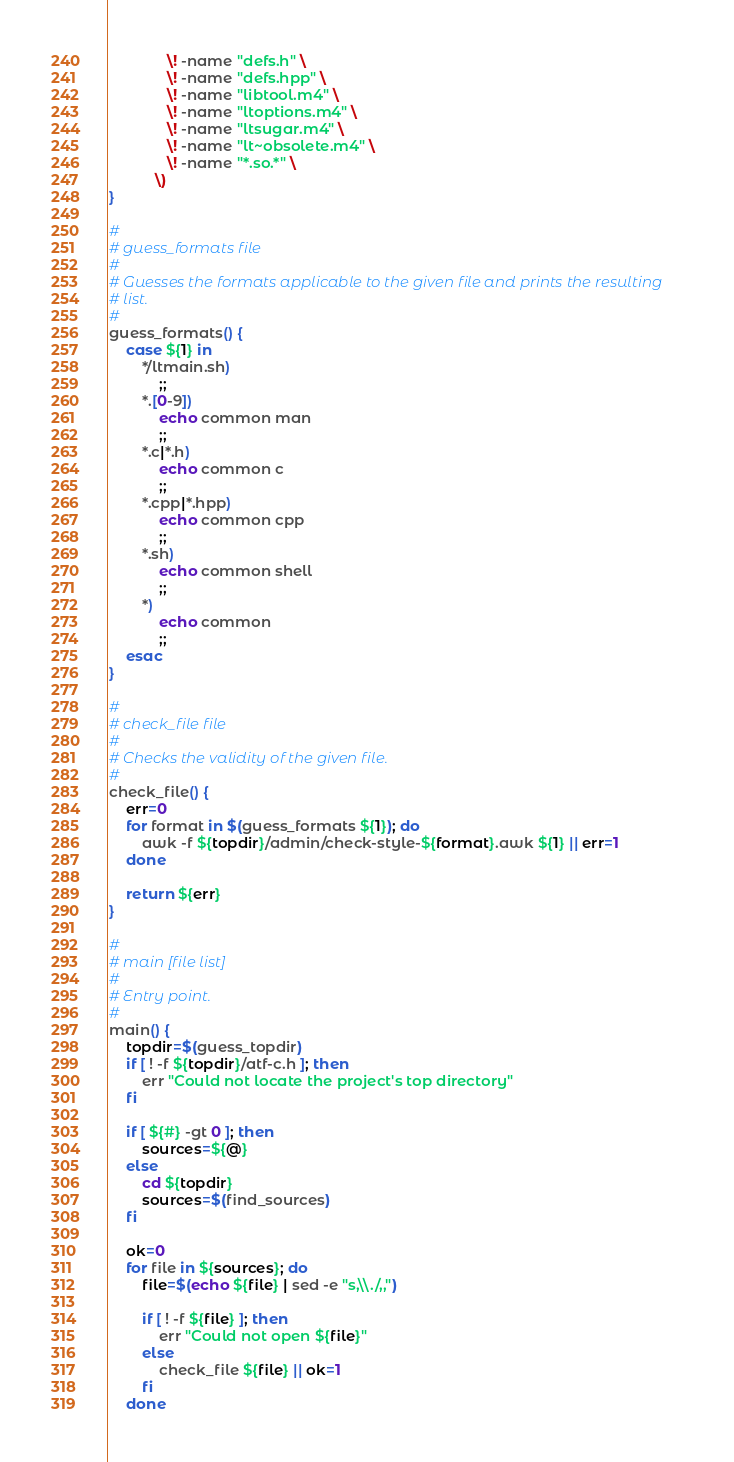<code> <loc_0><loc_0><loc_500><loc_500><_Bash_>              \! -name "defs.h" \
              \! -name "defs.hpp" \
              \! -name "libtool.m4" \
              \! -name "ltoptions.m4" \
              \! -name "ltsugar.m4" \
              \! -name "lt~obsolete.m4" \
              \! -name "*.so.*" \
           \)
}

#
# guess_formats file
#
# Guesses the formats applicable to the given file and prints the resulting
# list.
#
guess_formats() {
    case ${1} in
        */ltmain.sh)
            ;;
        *.[0-9])
            echo common man
            ;;
        *.c|*.h)
            echo common c
            ;;
        *.cpp|*.hpp)
            echo common cpp
            ;;
        *.sh)
            echo common shell
            ;;
        *)
            echo common
            ;;
    esac
}

#
# check_file file
#
# Checks the validity of the given file.
#
check_file() {
    err=0
    for format in $(guess_formats ${1}); do
        awk -f ${topdir}/admin/check-style-${format}.awk ${1} || err=1
    done

    return ${err}
}

#
# main [file list]
#
# Entry point.
#
main() {
    topdir=$(guess_topdir)
    if [ ! -f ${topdir}/atf-c.h ]; then
        err "Could not locate the project's top directory"
    fi

    if [ ${#} -gt 0 ]; then
        sources=${@}
    else
        cd ${topdir}
        sources=$(find_sources)
    fi

    ok=0
    for file in ${sources}; do
        file=$(echo ${file} | sed -e "s,\\./,,")

        if [ ! -f ${file} ]; then
            err "Could not open ${file}"
        else
            check_file ${file} || ok=1
        fi
    done
</code> 